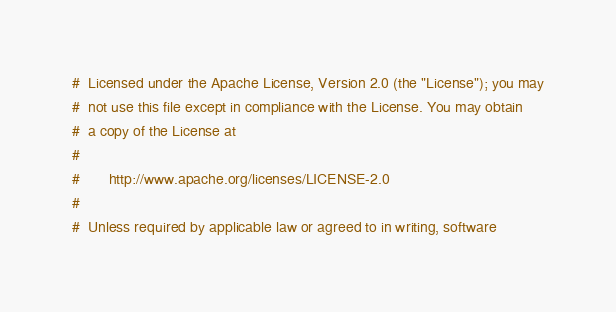<code> <loc_0><loc_0><loc_500><loc_500><_Python_>#  Licensed under the Apache License, Version 2.0 (the "License"); you may
#  not use this file except in compliance with the License. You may obtain
#  a copy of the License at
#
#       http://www.apache.org/licenses/LICENSE-2.0
#
#  Unless required by applicable law or agreed to in writing, software</code> 